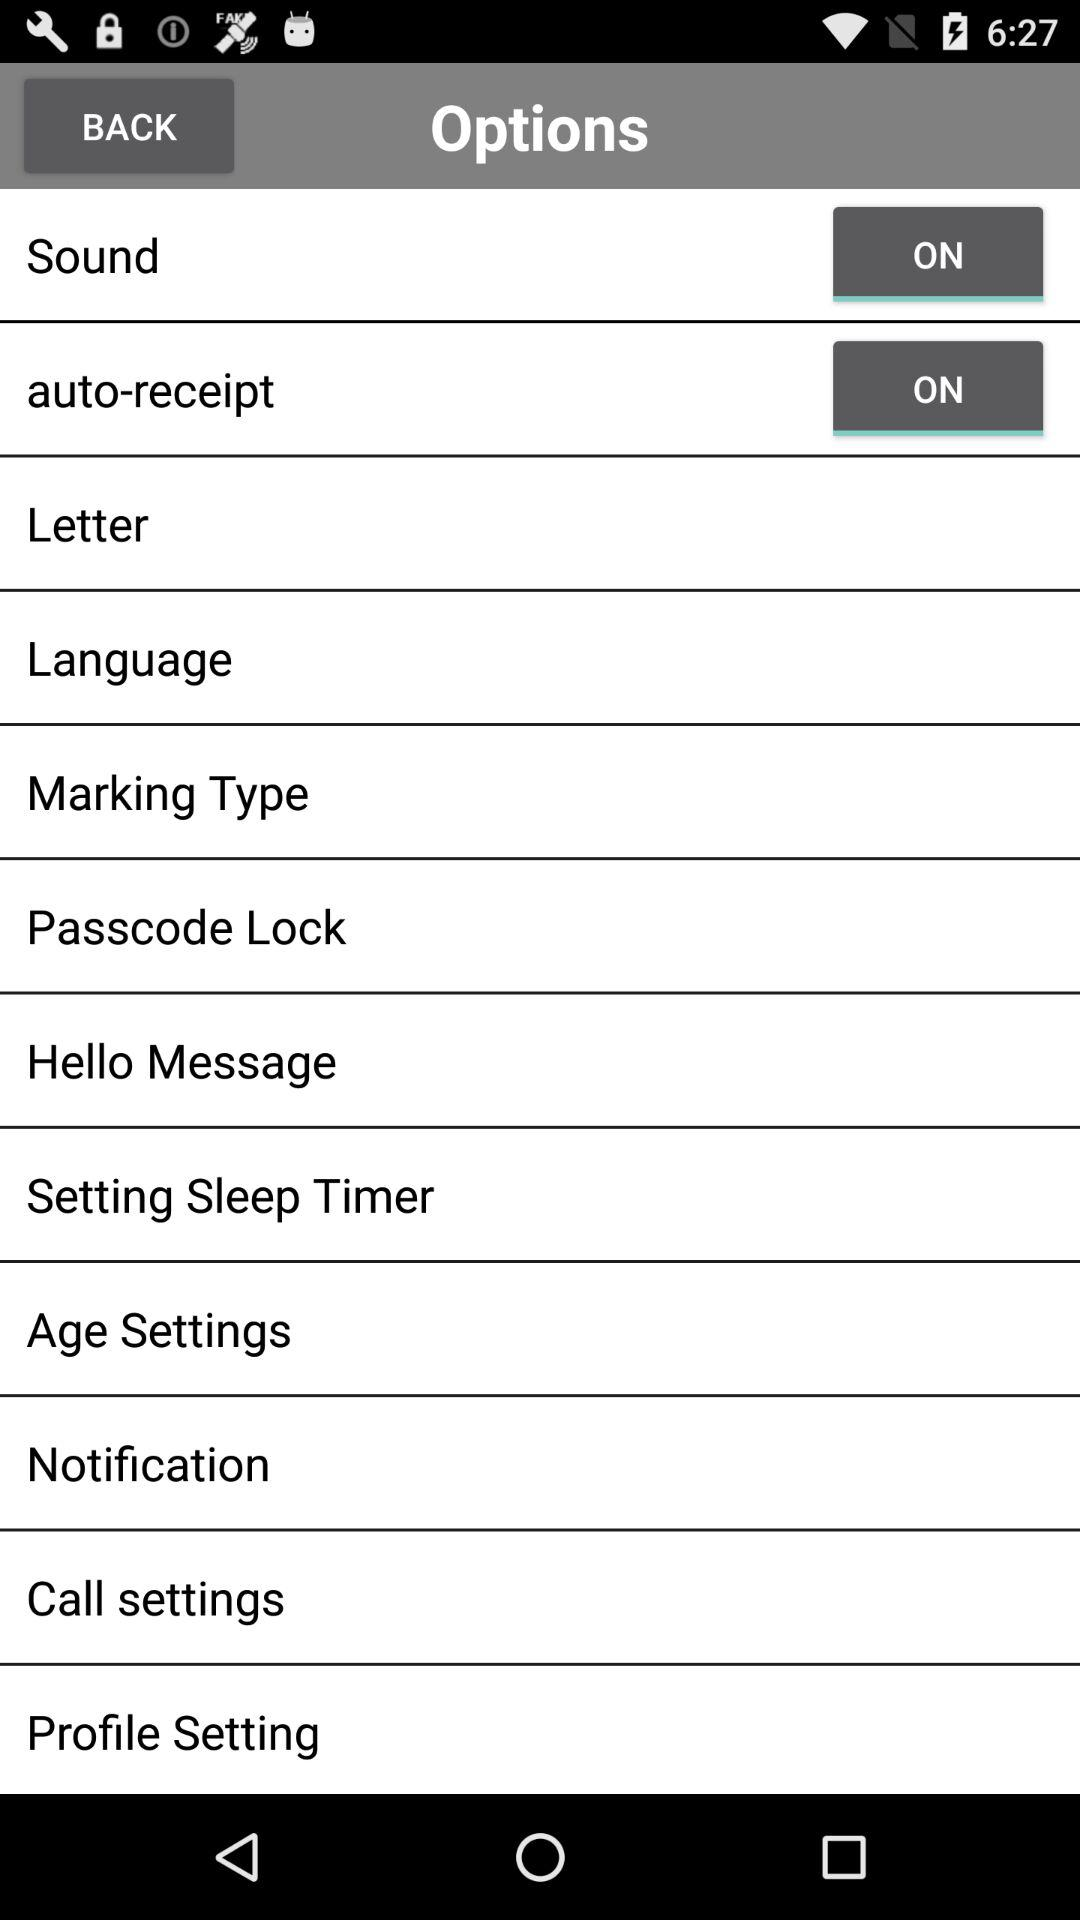How many settings are turned on?
Answer the question using a single word or phrase. 2 